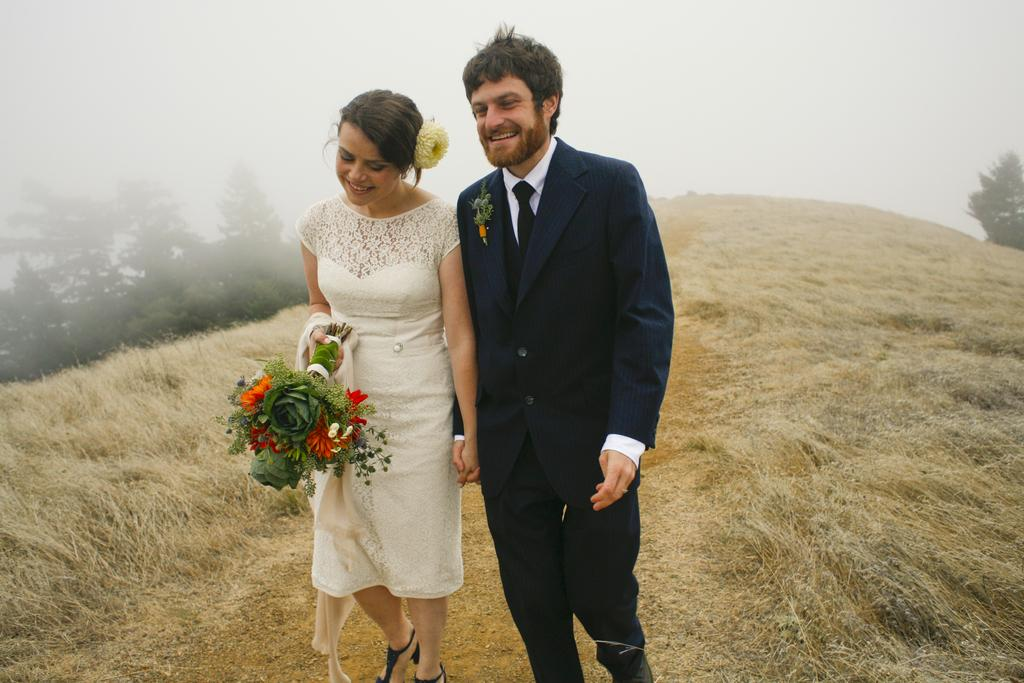Who is present in the image? There is a couple in the image. What are the couple doing in the image? The couple is holding each other and standing. What can be seen on either side of the couple? There are dried grass on either side of the couple. What type of meal is being prepared by the couple in the image? There is no meal being prepared in the image; the couple is simply holding each other. 